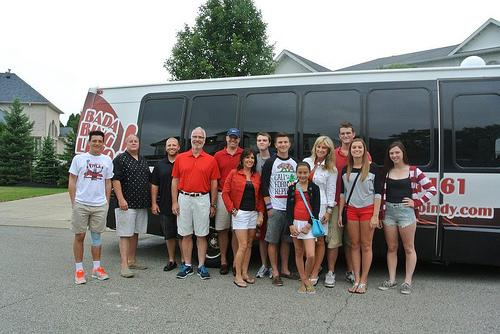What is happening in the scene with the people? A group of people are posing for a picture, wearing various attire like red shirts, black shirts, white shirts, black tank top, white jackets, and red jackets. Using descriptive language, describe the surroundings of the people in the image. The people are surrounded by a white bus with red writing, a tall green tree, and several people wearing different colored clothes, while a few of them have accessories like eyeglasses, blue hat, and a blue handbag. Comment on the nature of the objects in the scene. Most of the objects are people dressed in various attire along with some objects like a white bus, a green tree, different pairs of shoes, a blue hat, eyeglasses, a blue purse and a blue handbag. Briefly, provide a conceptual analysis of the image. The image captures a diverse group of people posing with various types of clothing and accessories, displaying a sense of unity, vibrancy, and casual atmosphere with a white bus and a tall green tree in the background. Identify the primary mode of transportation in this image. The primary mode of transportation in this image is a white bus with red writing. Determine the overall sentiment of this image. The overall sentiment of this image is happy and cheerful, as the people are posing for a picture and displaying vibrant attire. List the underlying emotions of the scene. Joy, happiness, and togetherness. What are the main attributes of the woman wearing the black tank top? The main attributes of the woman include a black tank top, positioning near the center of the group, and standing slightly taller than others around her. Enumerate the number of individuals wearing a red shirt and those wearing a black shirt. There are four people wearing a red shirt and four wearing a black shirt in this image. What is the most dominant color in this image? White is the most dominant color, featured on the bus and several people's clothing. What is the color of the sneakers that are directly adjacent to the beige shorts? bright orange Are the people in the image performing any specific activity? If yes, what is it? Yes, the people in the image are posing for a picture. Describe any interaction between objects in the image in a single sentence. People are posing for a picture with a bus and tall green tree in the background. Can you see the man holding an umbrella near the little girl? No, it's not mentioned in the image. Rewrite the following sentence in a more elaborate and detailed manner using the information available on the image: "A group of people is posing in front of the bus." A diverse group of people, wearing various colored clothes and accessories, are posing for a picture in front of a white bus with red writing, alongside a tall green tree behind the bus. Identify the color of the purse carried by the girl with the black sweater. blue Is there a woman who is wearing white shorts in the image? Yes, there is a woman wearing white shorts. Is the man wearing a green shirt standing near the tree? There is no mention of anyone wearing a green shirt. There is a mention of a tall green tree, but it is located behind the bus, not close to any person. In the image, find a person with black jacket and describe an item they have. The little girl with a black jacket is wearing a pair of black sneakers. Can you find any visible text or writing on the objects present in the image? Yes, there is red writing on the white bus. Explain if there is any activity shown by people in the image. People are posing for a picture. Which object is on the girl's shoulder who is wearing the black sweater? blue purse Describe any text or writing found on an object in the image. There is red writing on the white bus. Select the correct option regarding an item worn by the woman wearing a black tank top: (a) red sandals (b) bright orange sneakers (c) black sneakers (b) bright orange sneakers Describe any facial feature of the person in a red shirt. I cannot describe any facial feature since I cannot see the image. Rephrase the given sentence with added information provided by the image: "A man is wearing a red shirt." A man wearing a red shirt is also wearing beige shorts with a belt and a pair of black sneakers. Write the description of the bus and its surroundings found in the image. A long white bus with red writing is parked behind a group of people, with a tall green tree behind it. Determine the accessory that the person in blue hat is wearing. The man in the blue hat is also wearing eyeglasses. What's the color of the shorts the man with a red shirt is wearing? tan 